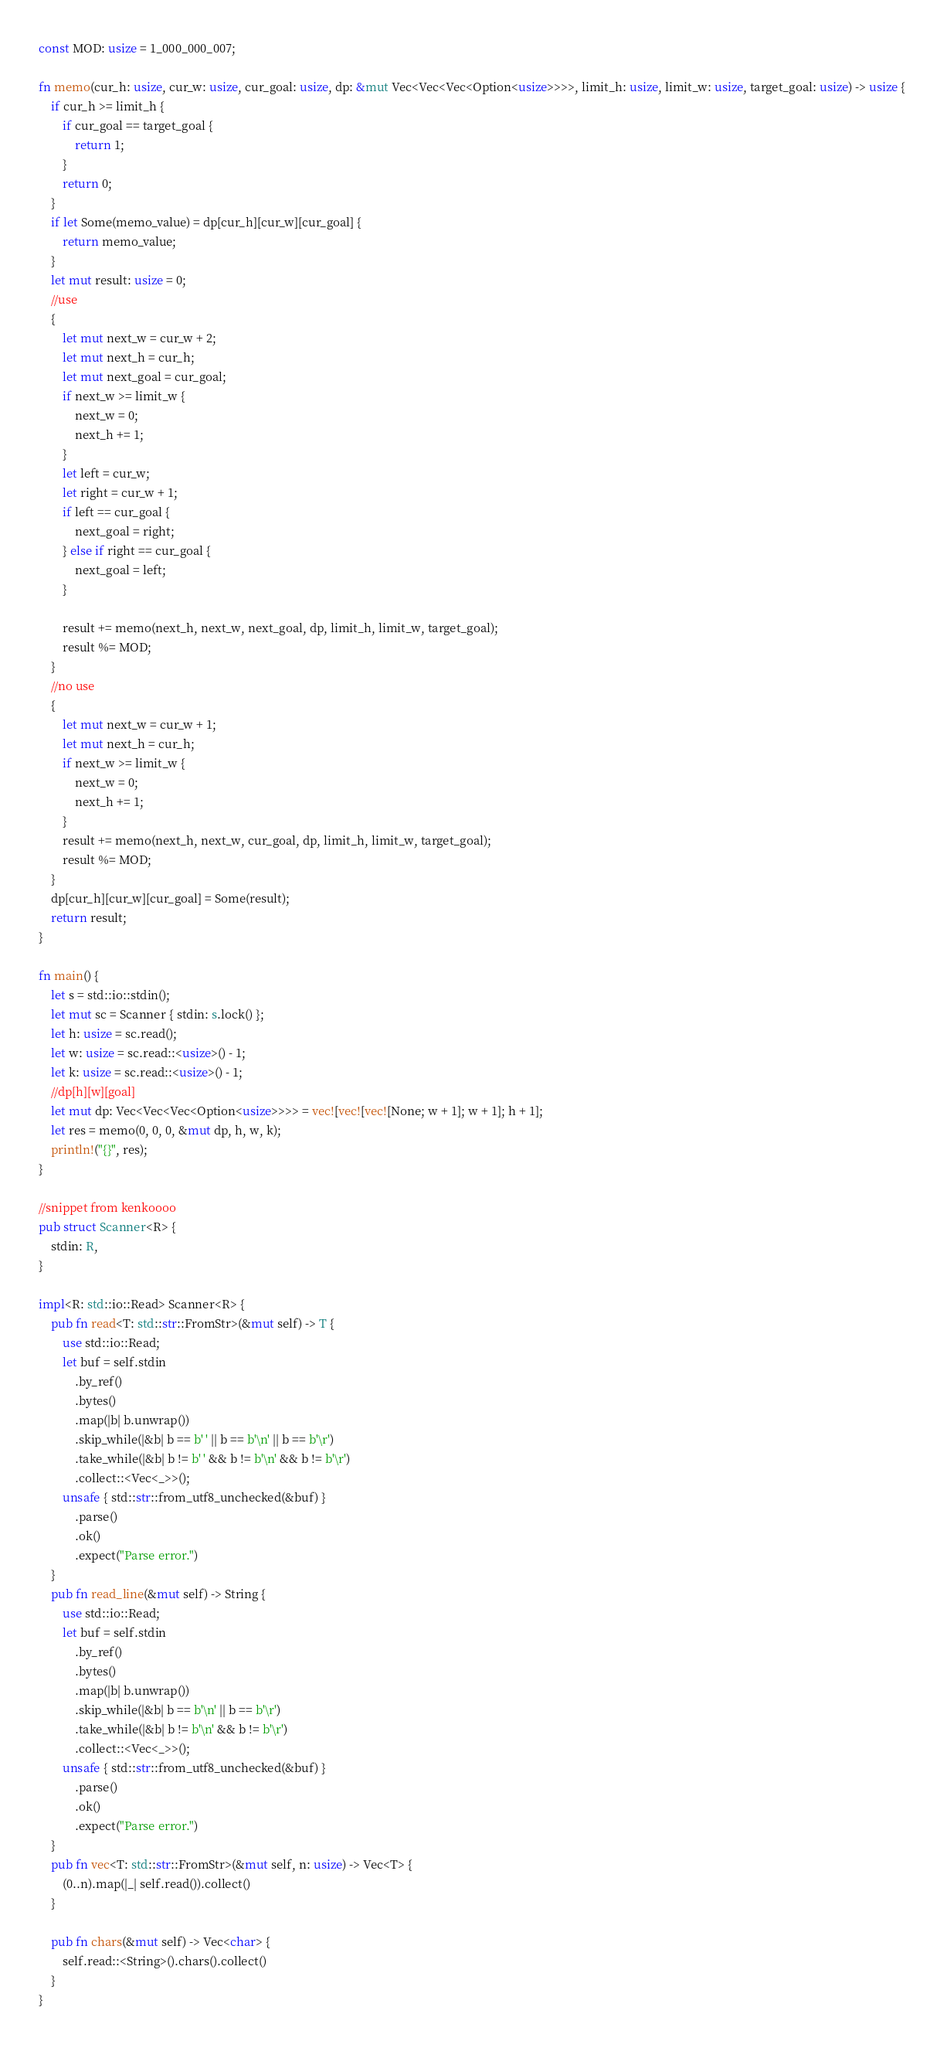<code> <loc_0><loc_0><loc_500><loc_500><_Rust_>const MOD: usize = 1_000_000_007;

fn memo(cur_h: usize, cur_w: usize, cur_goal: usize, dp: &mut Vec<Vec<Vec<Option<usize>>>>, limit_h: usize, limit_w: usize, target_goal: usize) -> usize {
    if cur_h >= limit_h {
        if cur_goal == target_goal {
            return 1;
        }
        return 0;
    }
    if let Some(memo_value) = dp[cur_h][cur_w][cur_goal] {
        return memo_value;
    }
    let mut result: usize = 0;
    //use
    {
        let mut next_w = cur_w + 2;
        let mut next_h = cur_h;
        let mut next_goal = cur_goal;
        if next_w >= limit_w {
            next_w = 0;
            next_h += 1;
        }
        let left = cur_w;
        let right = cur_w + 1;
        if left == cur_goal {
            next_goal = right;
        } else if right == cur_goal {
            next_goal = left;
        }

        result += memo(next_h, next_w, next_goal, dp, limit_h, limit_w, target_goal);
        result %= MOD;
    }
    //no use
    {
        let mut next_w = cur_w + 1;
        let mut next_h = cur_h;
        if next_w >= limit_w {
            next_w = 0;
            next_h += 1;
        }
        result += memo(next_h, next_w, cur_goal, dp, limit_h, limit_w, target_goal);
        result %= MOD;
    }
    dp[cur_h][cur_w][cur_goal] = Some(result);
    return result;
}

fn main() {
    let s = std::io::stdin();
    let mut sc = Scanner { stdin: s.lock() };
    let h: usize = sc.read();
    let w: usize = sc.read::<usize>() - 1;
    let k: usize = sc.read::<usize>() - 1;
    //dp[h][w][goal]
    let mut dp: Vec<Vec<Vec<Option<usize>>>> = vec![vec![vec![None; w + 1]; w + 1]; h + 1];
    let res = memo(0, 0, 0, &mut dp, h, w, k);
    println!("{}", res);
}

//snippet from kenkoooo
pub struct Scanner<R> {
    stdin: R,
}

impl<R: std::io::Read> Scanner<R> {
    pub fn read<T: std::str::FromStr>(&mut self) -> T {
        use std::io::Read;
        let buf = self.stdin
            .by_ref()
            .bytes()
            .map(|b| b.unwrap())
            .skip_while(|&b| b == b' ' || b == b'\n' || b == b'\r')
            .take_while(|&b| b != b' ' && b != b'\n' && b != b'\r')
            .collect::<Vec<_>>();
        unsafe { std::str::from_utf8_unchecked(&buf) }
            .parse()
            .ok()
            .expect("Parse error.")
    }
    pub fn read_line(&mut self) -> String {
        use std::io::Read;
        let buf = self.stdin
            .by_ref()
            .bytes()
            .map(|b| b.unwrap())
            .skip_while(|&b| b == b'\n' || b == b'\r')
            .take_while(|&b| b != b'\n' && b != b'\r')
            .collect::<Vec<_>>();
        unsafe { std::str::from_utf8_unchecked(&buf) }
            .parse()
            .ok()
            .expect("Parse error.")
    }
    pub fn vec<T: std::str::FromStr>(&mut self, n: usize) -> Vec<T> {
        (0..n).map(|_| self.read()).collect()
    }

    pub fn chars(&mut self) -> Vec<char> {
        self.read::<String>().chars().collect()
    }
}
</code> 